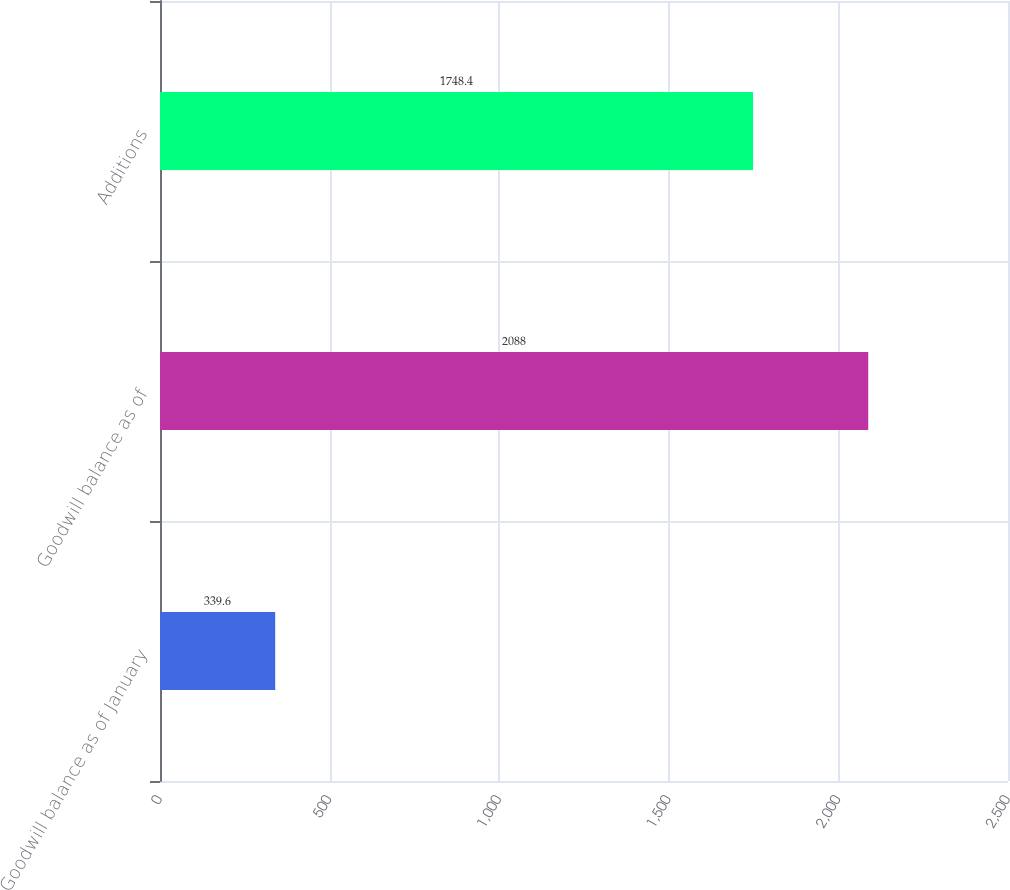Convert chart to OTSL. <chart><loc_0><loc_0><loc_500><loc_500><bar_chart><fcel>Goodwill balance as of January<fcel>Goodwill balance as of<fcel>Additions<nl><fcel>339.6<fcel>2088<fcel>1748.4<nl></chart> 